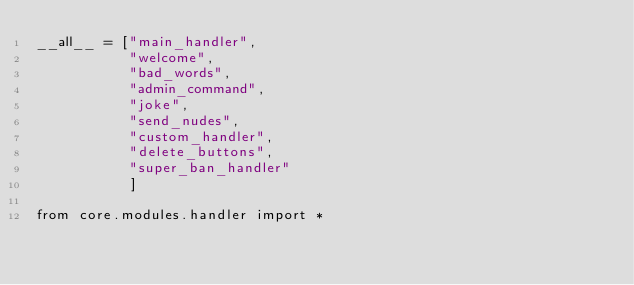<code> <loc_0><loc_0><loc_500><loc_500><_Python_>__all__ = ["main_handler",
           "welcome",
           "bad_words",
           "admin_command",
           "joke",
           "send_nudes",
           "custom_handler",
           "delete_buttons",
           "super_ban_handler"
           ]

from core.modules.handler import *</code> 